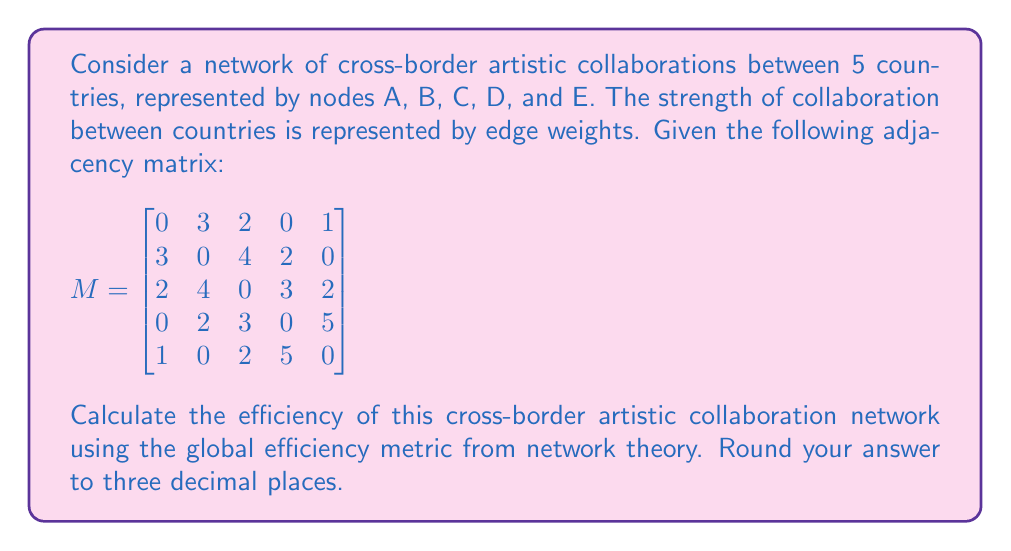Solve this math problem. To solve this problem, we'll follow these steps:

1) The global efficiency of a network is defined as:

   $$E = \frac{1}{n(n-1)} \sum_{i\neq j} \frac{1}{d_{ij}}$$

   where $n$ is the number of nodes, and $d_{ij}$ is the shortest path length between nodes i and j.

2) First, we need to calculate the shortest path lengths between all pairs of nodes. We can use the Floyd-Warshall algorithm or Dijkstra's algorithm for this. The result is:

   $$D = \begin{bmatrix}
   0 & 3 & 2 & 5 & 1 \\
   3 & 0 & 4 & 2 & 5 \\
   2 & 4 & 0 & 3 & 2 \\
   5 & 2 & 3 & 0 & 5 \\
   1 & 5 & 2 & 5 & 0
   \end{bmatrix}$$

3) Now, we calculate $\frac{1}{d_{ij}}$ for each pair (excluding self-pairs):

   $$\frac{1}{3} + \frac{1}{2} + \frac{1}{5} + 1 + \frac{1}{3} + \frac{1}{4} + \frac{1}{2} + \frac{1}{5} + \frac{1}{2} + \frac{1}{4} + \frac{1}{3} + \frac{1}{2} + \frac{1}{5} + \frac{1}{2} + \frac{1}{3} + \frac{1}{5} + 1 + \frac{1}{2} + \frac{1}{5} + 1$$

4) Sum these values:

   $0.333 + 0.5 + 0.2 + 1 + 0.333 + 0.25 + 0.5 + 0.2 + 0.5 + 0.25 + 0.333 + 0.5 + 0.2 + 0.5 + 0.333 + 0.2 + 1 + 0.5 + 0.2 + 1 = 8.833$

5) Multiply by $\frac{1}{n(n-1)} = \frac{1}{5(5-1)} = \frac{1}{20}$:

   $E = \frac{8.833}{20} = 0.44165$

6) Rounding to three decimal places: 0.442

This efficiency value indicates a moderate level of connectivity in the cross-border artistic collaboration network, suggesting room for improvement in fostering more direct collaborations between countries.
Answer: 0.442 